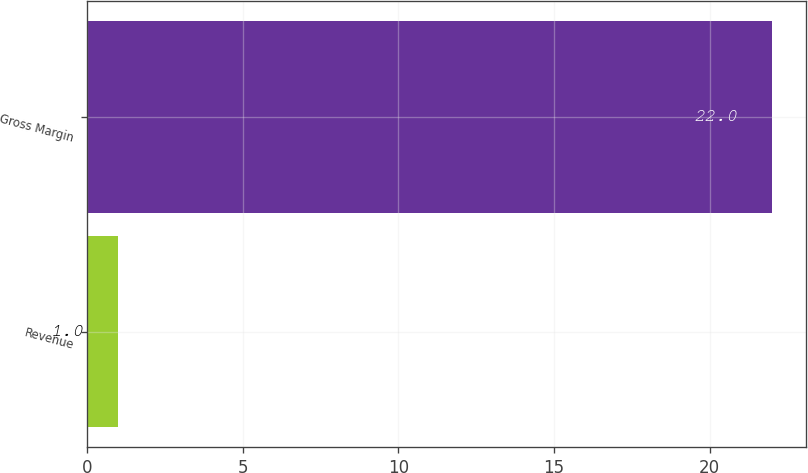Convert chart. <chart><loc_0><loc_0><loc_500><loc_500><bar_chart><fcel>Revenue<fcel>Gross Margin<nl><fcel>1<fcel>22<nl></chart> 